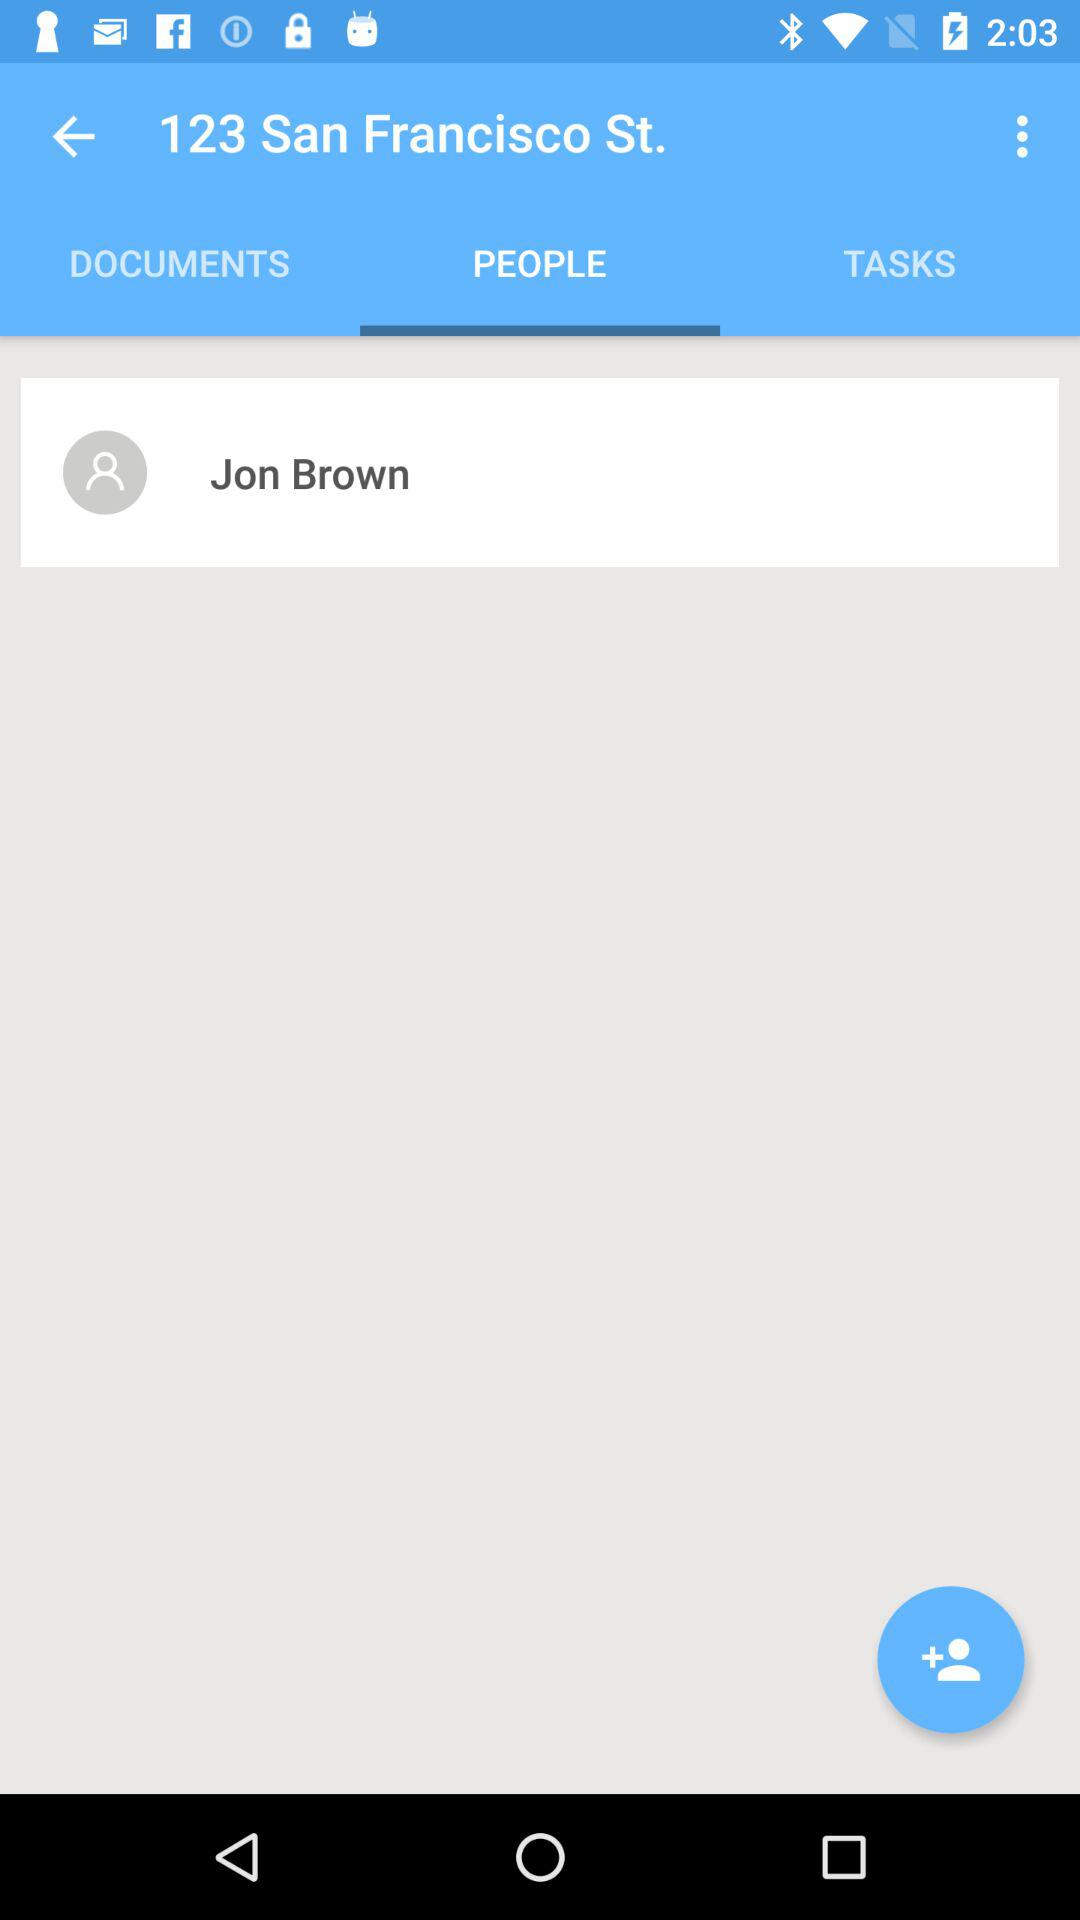What address has been given? The given address is 123 San Francisco Street. 